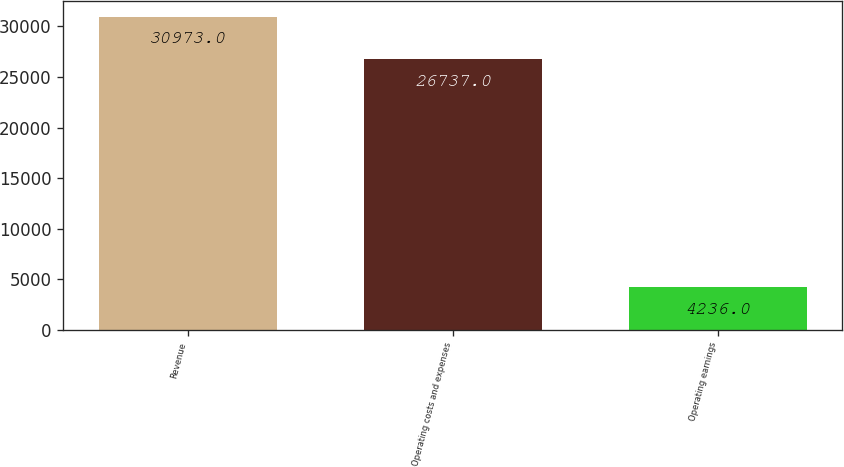Convert chart to OTSL. <chart><loc_0><loc_0><loc_500><loc_500><bar_chart><fcel>Revenue<fcel>Operating costs and expenses<fcel>Operating earnings<nl><fcel>30973<fcel>26737<fcel>4236<nl></chart> 